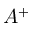<formula> <loc_0><loc_0><loc_500><loc_500>A ^ { + }</formula> 